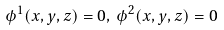Convert formula to latex. <formula><loc_0><loc_0><loc_500><loc_500>\phi ^ { 1 } ( x , y , z ) = 0 , \, \phi ^ { 2 } ( x , y , z ) = 0</formula> 